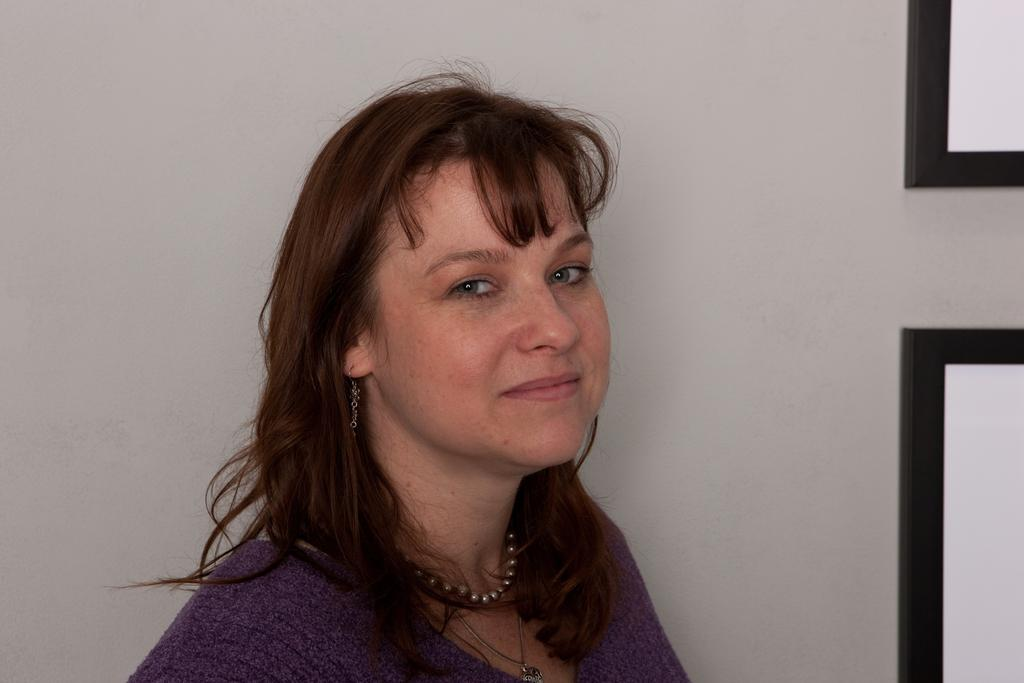Who is the main subject in the image? There is a woman in the image. What is the woman wearing? The woman is wearing a violet dress. What expression does the woman have? The woman is smiling. What can be seen in the background of the image? There is a white color wall in the background of the image. What type of design can be seen on the woman's bag in the image? There is no bag present in the image, so it is not possible to determine the design on it. 